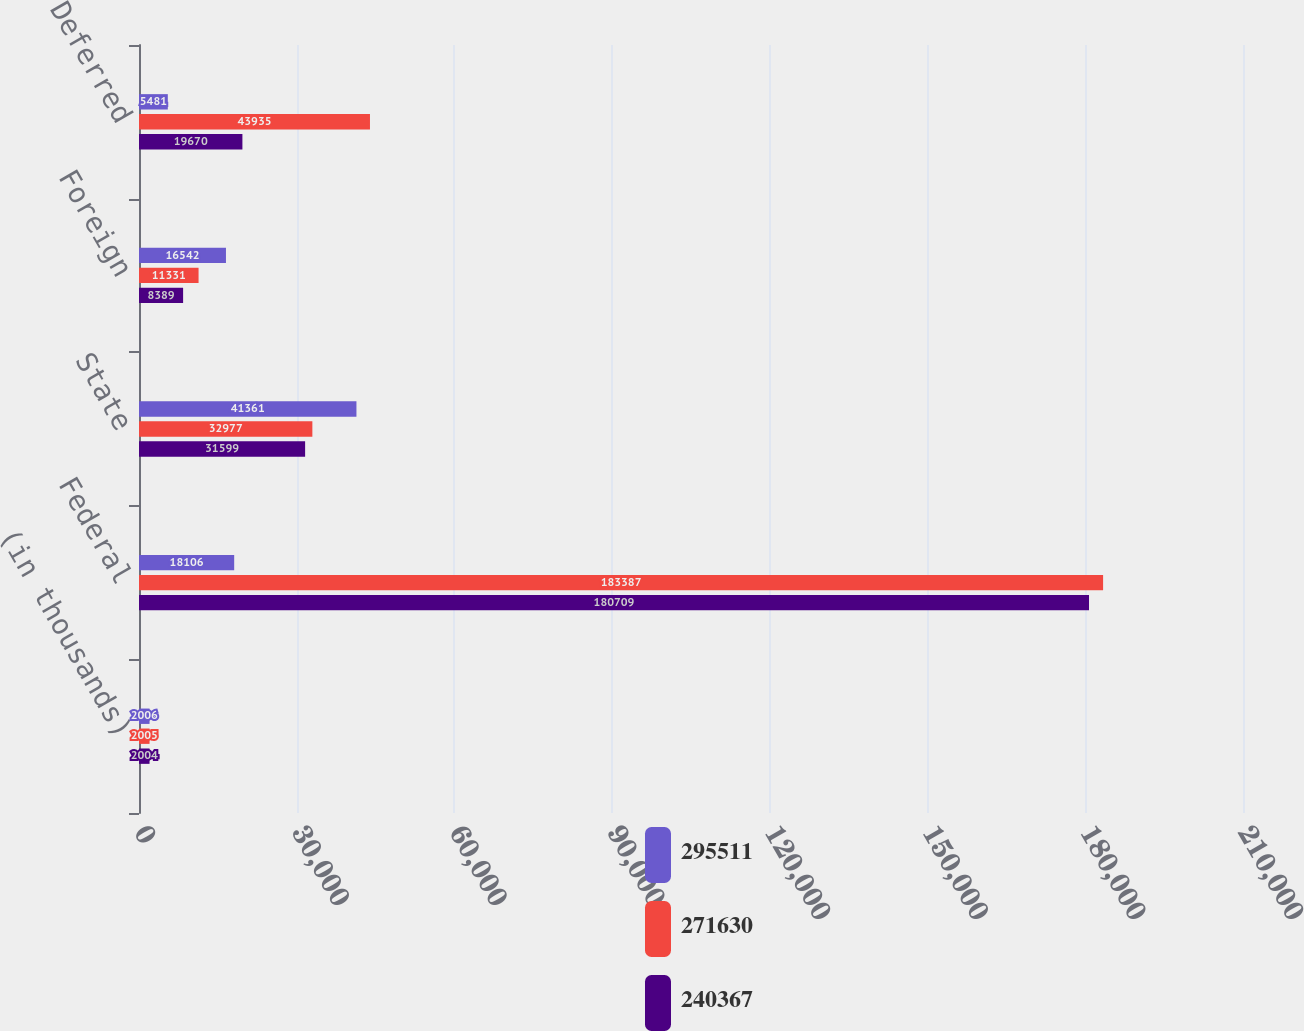Convert chart to OTSL. <chart><loc_0><loc_0><loc_500><loc_500><stacked_bar_chart><ecel><fcel>(in thousands)<fcel>Federal<fcel>State<fcel>Foreign<fcel>Deferred<nl><fcel>295511<fcel>2006<fcel>18106<fcel>41361<fcel>16542<fcel>5481<nl><fcel>271630<fcel>2005<fcel>183387<fcel>32977<fcel>11331<fcel>43935<nl><fcel>240367<fcel>2004<fcel>180709<fcel>31599<fcel>8389<fcel>19670<nl></chart> 